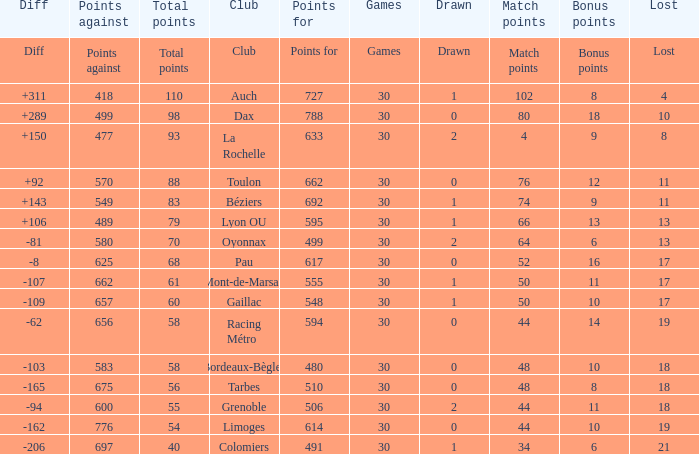What is the number of games for a club that has a value of 595 for points for? 30.0. 